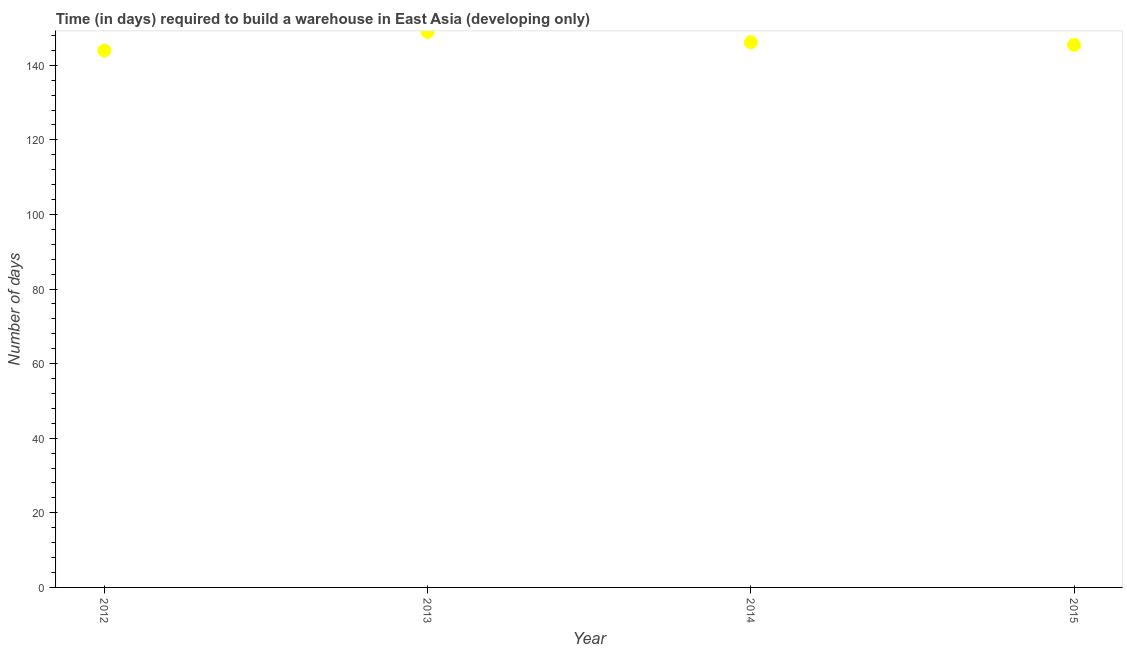What is the time required to build a warehouse in 2013?
Ensure brevity in your answer.  148.98. Across all years, what is the maximum time required to build a warehouse?
Your answer should be compact. 148.98. Across all years, what is the minimum time required to build a warehouse?
Keep it short and to the point. 143.95. What is the sum of the time required to build a warehouse?
Offer a terse response. 584.54. What is the difference between the time required to build a warehouse in 2014 and 2015?
Your answer should be compact. 0.71. What is the average time required to build a warehouse per year?
Offer a terse response. 146.14. What is the median time required to build a warehouse?
Offer a very short reply. 145.81. In how many years, is the time required to build a warehouse greater than 100 days?
Offer a terse response. 4. Do a majority of the years between 2015 and 2014 (inclusive) have time required to build a warehouse greater than 128 days?
Your answer should be very brief. No. What is the ratio of the time required to build a warehouse in 2012 to that in 2014?
Give a very brief answer. 0.98. Is the time required to build a warehouse in 2013 less than that in 2015?
Keep it short and to the point. No. What is the difference between the highest and the second highest time required to build a warehouse?
Keep it short and to the point. 2.81. Is the sum of the time required to build a warehouse in 2013 and 2014 greater than the maximum time required to build a warehouse across all years?
Offer a terse response. Yes. What is the difference between the highest and the lowest time required to build a warehouse?
Ensure brevity in your answer.  5.03. How many dotlines are there?
Provide a short and direct response. 1. How many years are there in the graph?
Ensure brevity in your answer.  4. What is the difference between two consecutive major ticks on the Y-axis?
Make the answer very short. 20. Does the graph contain any zero values?
Give a very brief answer. No. Does the graph contain grids?
Provide a succinct answer. No. What is the title of the graph?
Your answer should be compact. Time (in days) required to build a warehouse in East Asia (developing only). What is the label or title of the Y-axis?
Give a very brief answer. Number of days. What is the Number of days in 2012?
Provide a short and direct response. 143.95. What is the Number of days in 2013?
Ensure brevity in your answer.  148.98. What is the Number of days in 2014?
Provide a short and direct response. 146.17. What is the Number of days in 2015?
Your response must be concise. 145.45. What is the difference between the Number of days in 2012 and 2013?
Your answer should be compact. -5.03. What is the difference between the Number of days in 2012 and 2014?
Your answer should be very brief. -2.22. What is the difference between the Number of days in 2012 and 2015?
Offer a terse response. -1.51. What is the difference between the Number of days in 2013 and 2014?
Keep it short and to the point. 2.81. What is the difference between the Number of days in 2013 and 2015?
Provide a short and direct response. 3.52. What is the difference between the Number of days in 2014 and 2015?
Keep it short and to the point. 0.71. What is the ratio of the Number of days in 2012 to that in 2014?
Your response must be concise. 0.98. What is the ratio of the Number of days in 2012 to that in 2015?
Your answer should be compact. 0.99. What is the ratio of the Number of days in 2013 to that in 2014?
Your response must be concise. 1.02. What is the ratio of the Number of days in 2013 to that in 2015?
Provide a succinct answer. 1.02. 